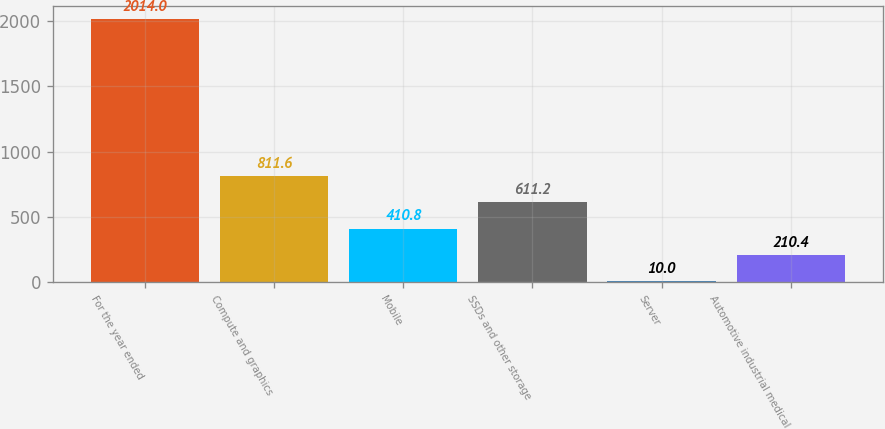Convert chart to OTSL. <chart><loc_0><loc_0><loc_500><loc_500><bar_chart><fcel>For the year ended<fcel>Compute and graphics<fcel>Mobile<fcel>SSDs and other storage<fcel>Server<fcel>Automotive industrial medical<nl><fcel>2014<fcel>811.6<fcel>410.8<fcel>611.2<fcel>10<fcel>210.4<nl></chart> 